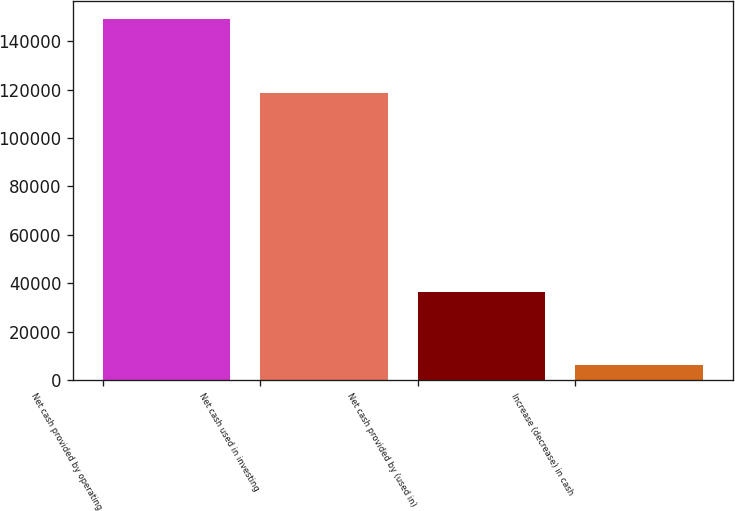Convert chart. <chart><loc_0><loc_0><loc_500><loc_500><bar_chart><fcel>Net cash provided by operating<fcel>Net cash used in investing<fcel>Net cash provided by (used in)<fcel>Increase (decrease) in cash<nl><fcel>148958<fcel>118807<fcel>36293<fcel>6142<nl></chart> 